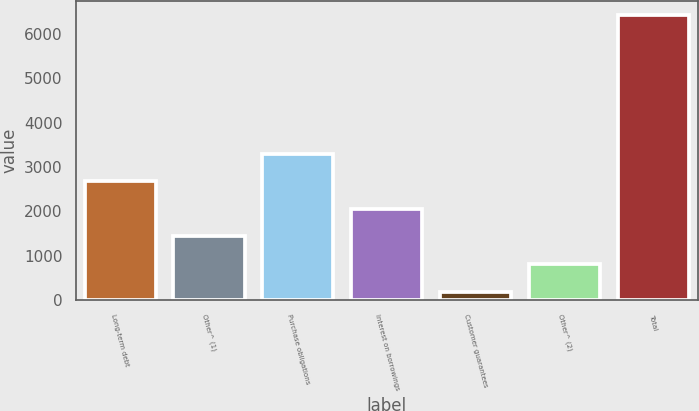Convert chart to OTSL. <chart><loc_0><loc_0><loc_500><loc_500><bar_chart><fcel>Long-term debt<fcel>Other^ (1)<fcel>Purchase obligations<fcel>Interest on borrowings<fcel>Customer guarantees<fcel>Other^ (2)<fcel>Total<nl><fcel>2681.8<fcel>1439.4<fcel>3303<fcel>2060.6<fcel>197<fcel>818.2<fcel>6409<nl></chart> 